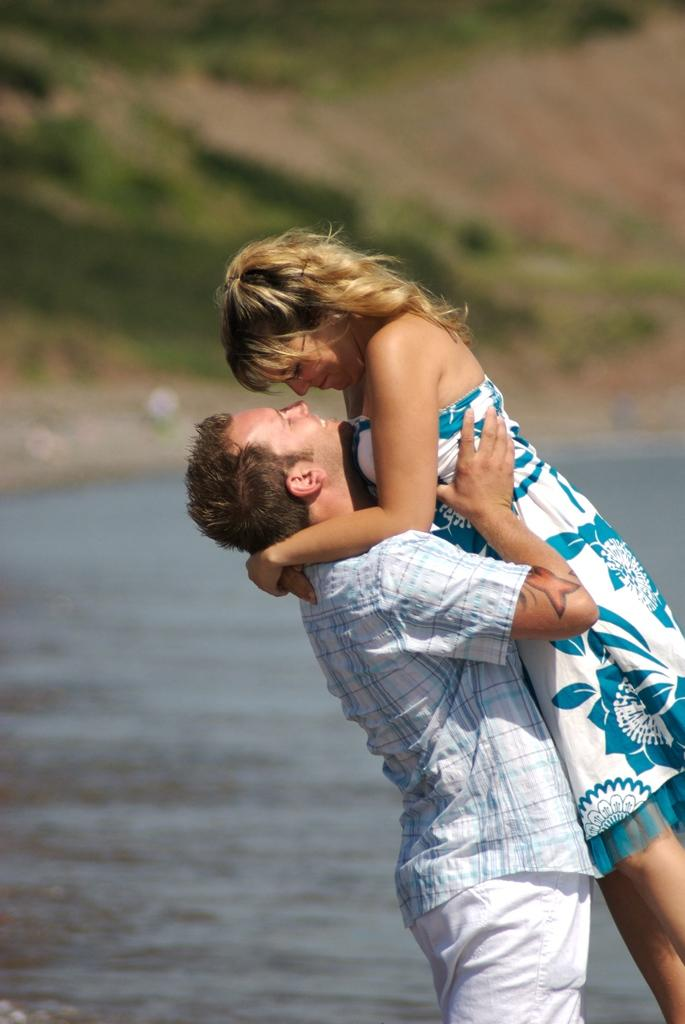Who is the main subject in the image? There is a man in the image. What is the man doing in the image? The man is lifting a woman with his hands. What can be seen in the background of the image? There is water and plants visible in the image. What type of property does the man's aunt own in the image? There is no mention of an aunt or property in the image. 